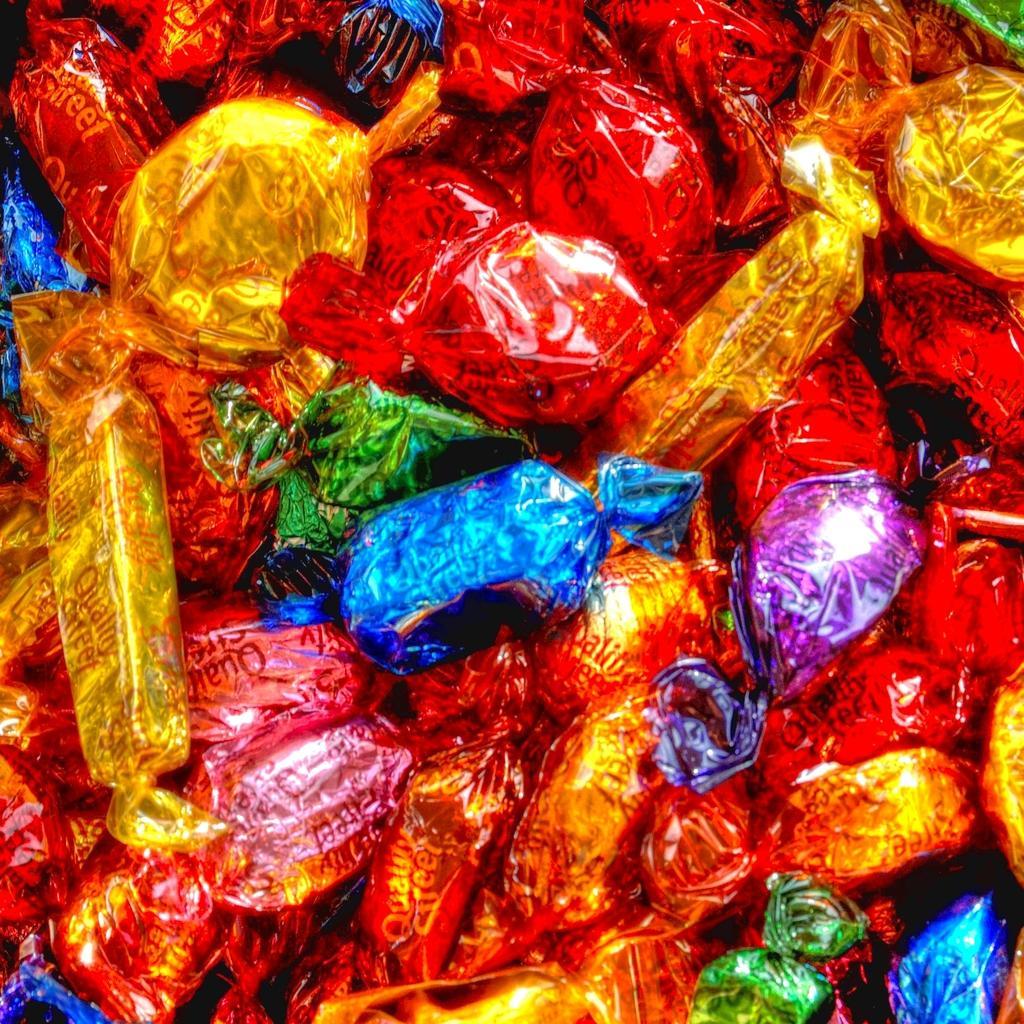How would you summarize this image in a sentence or two? In this image, we can see there are chocolate having red, golden, blue, violet, pink and green color covers. 